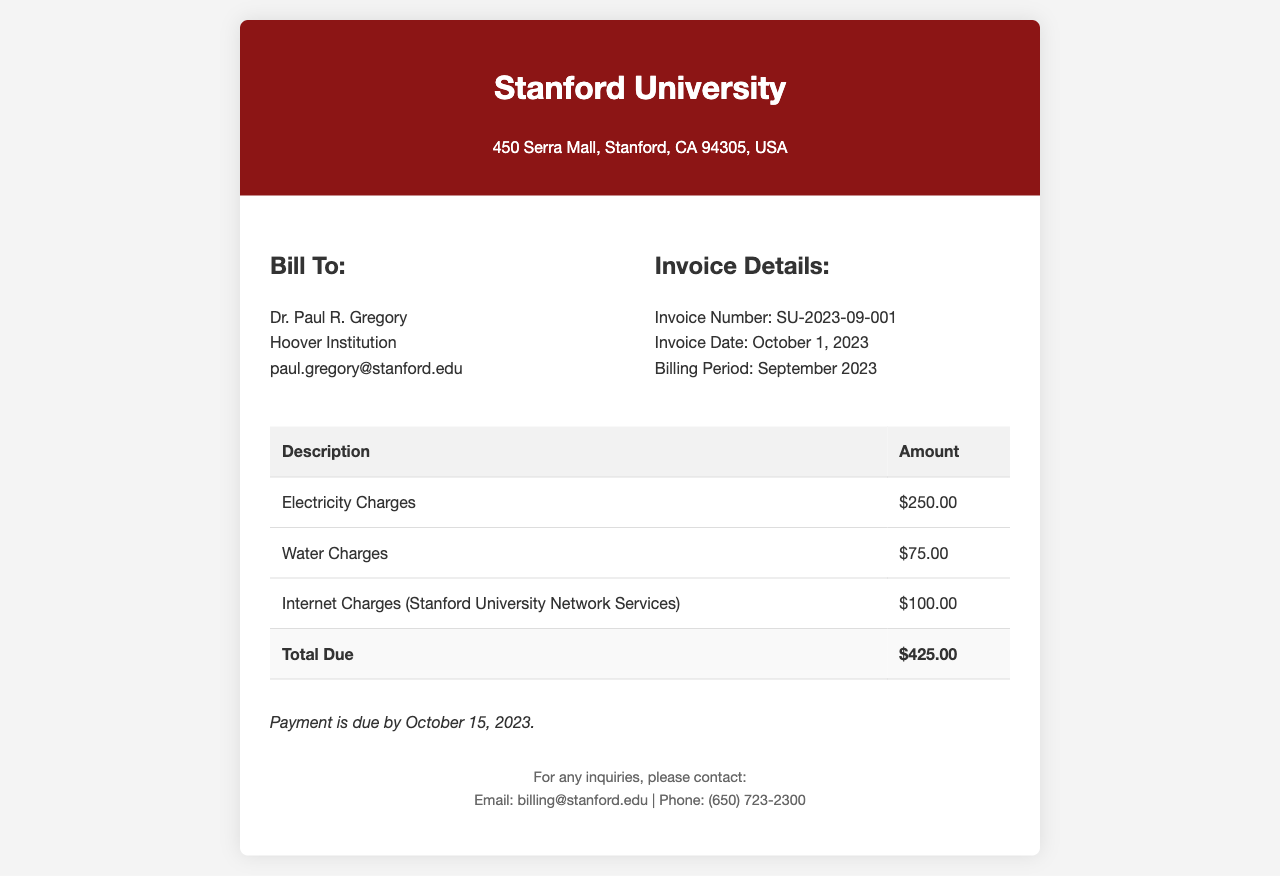What is the invoice number? The invoice number is specified in the document details under "Invoice Details."
Answer: SU-2023-09-001 What is the total amount due? The total due is calculated as the sum of electricity, water, and internet charges listed in the invoice.
Answer: $425.00 When is the payment due by? The payment due date is stated clearly in the payment terms section of the invoice.
Answer: October 15, 2023 What is the amount for water charges? The amount for water charges is detailed in the charges table of the document.
Answer: $75.00 Who is the bill addressed to? The recipient of the bill is listed under "Bill To" in the document.
Answer: Dr. Paul R. Gregory What is the billing period for this invoice? The billing period is indicated in the invoice details section.
Answer: September 2023 How much is charged for internet services? The internet charges are specifically mentioned in the table of charges.
Answer: $100.00 What is the address of Stanford University? The address is included at the top of the invoice in the header section.
Answer: 450 Serra Mall, Stanford, CA 94305, USA What percentage of the total bill is attributed to electricity? This requires calculating the share of electricity charges in the total bill amount.
Answer: 58.82% 